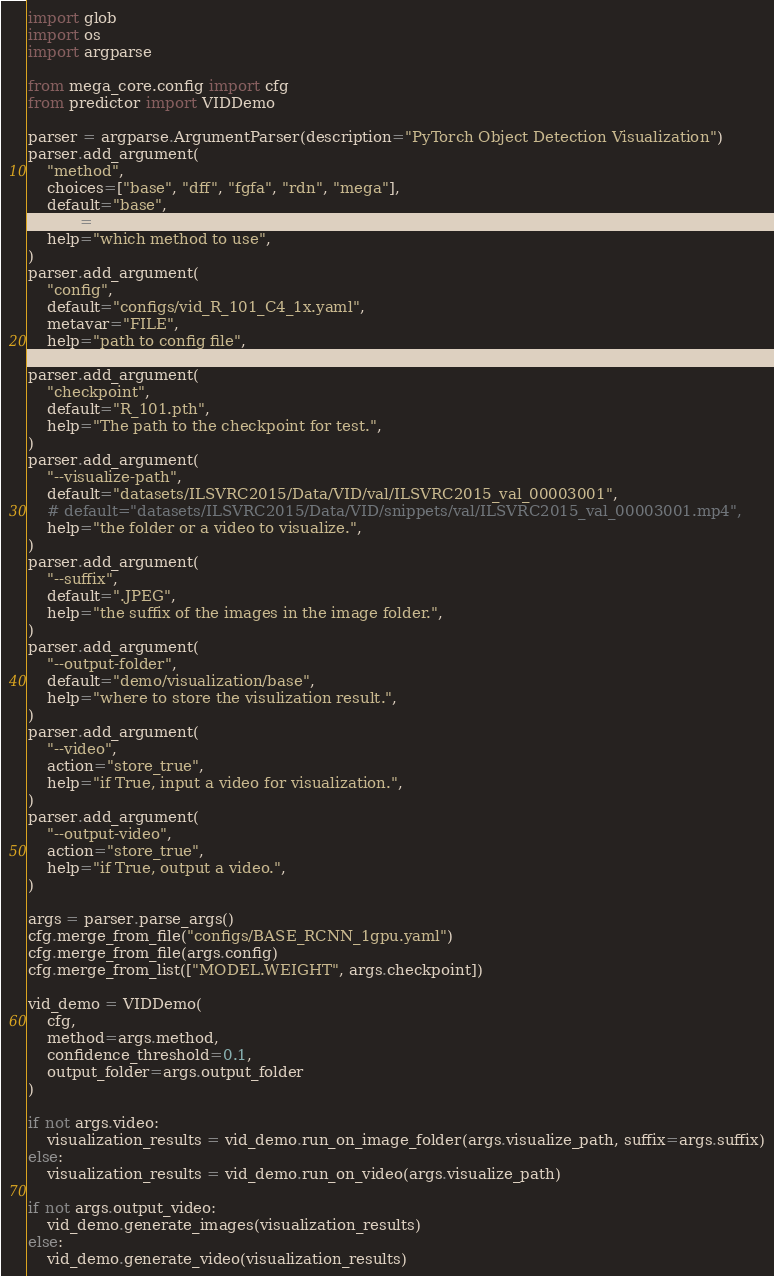<code> <loc_0><loc_0><loc_500><loc_500><_Python_>import glob
import os
import argparse

from mega_core.config import cfg
from predictor import VIDDemo

parser = argparse.ArgumentParser(description="PyTorch Object Detection Visualization")
parser.add_argument(
    "method",
    choices=["base", "dff", "fgfa", "rdn", "mega"],
    default="base",
    type=str,
    help="which method to use",
)
parser.add_argument(
    "config",
    default="configs/vid_R_101_C4_1x.yaml",
    metavar="FILE",
    help="path to config file",
)
parser.add_argument(
    "checkpoint",
    default="R_101.pth",
    help="The path to the checkpoint for test.",
)
parser.add_argument(
    "--visualize-path",
    default="datasets/ILSVRC2015/Data/VID/val/ILSVRC2015_val_00003001",
    # default="datasets/ILSVRC2015/Data/VID/snippets/val/ILSVRC2015_val_00003001.mp4",
    help="the folder or a video to visualize.",
)
parser.add_argument(
    "--suffix",
    default=".JPEG",
    help="the suffix of the images in the image folder.",
)
parser.add_argument(
    "--output-folder",
    default="demo/visualization/base",
    help="where to store the visulization result.",
)
parser.add_argument(
    "--video",
    action="store_true",
    help="if True, input a video for visualization.",
)
parser.add_argument(
    "--output-video",
    action="store_true",
    help="if True, output a video.",
)

args = parser.parse_args()
cfg.merge_from_file("configs/BASE_RCNN_1gpu.yaml")
cfg.merge_from_file(args.config)
cfg.merge_from_list(["MODEL.WEIGHT", args.checkpoint])

vid_demo = VIDDemo(
    cfg,
    method=args.method,
    confidence_threshold=0.1,
    output_folder=args.output_folder
)

if not args.video:
    visualization_results = vid_demo.run_on_image_folder(args.visualize_path, suffix=args.suffix)
else:
    visualization_results = vid_demo.run_on_video(args.visualize_path)

if not args.output_video:
    vid_demo.generate_images(visualization_results)
else:
    vid_demo.generate_video(visualization_results)</code> 